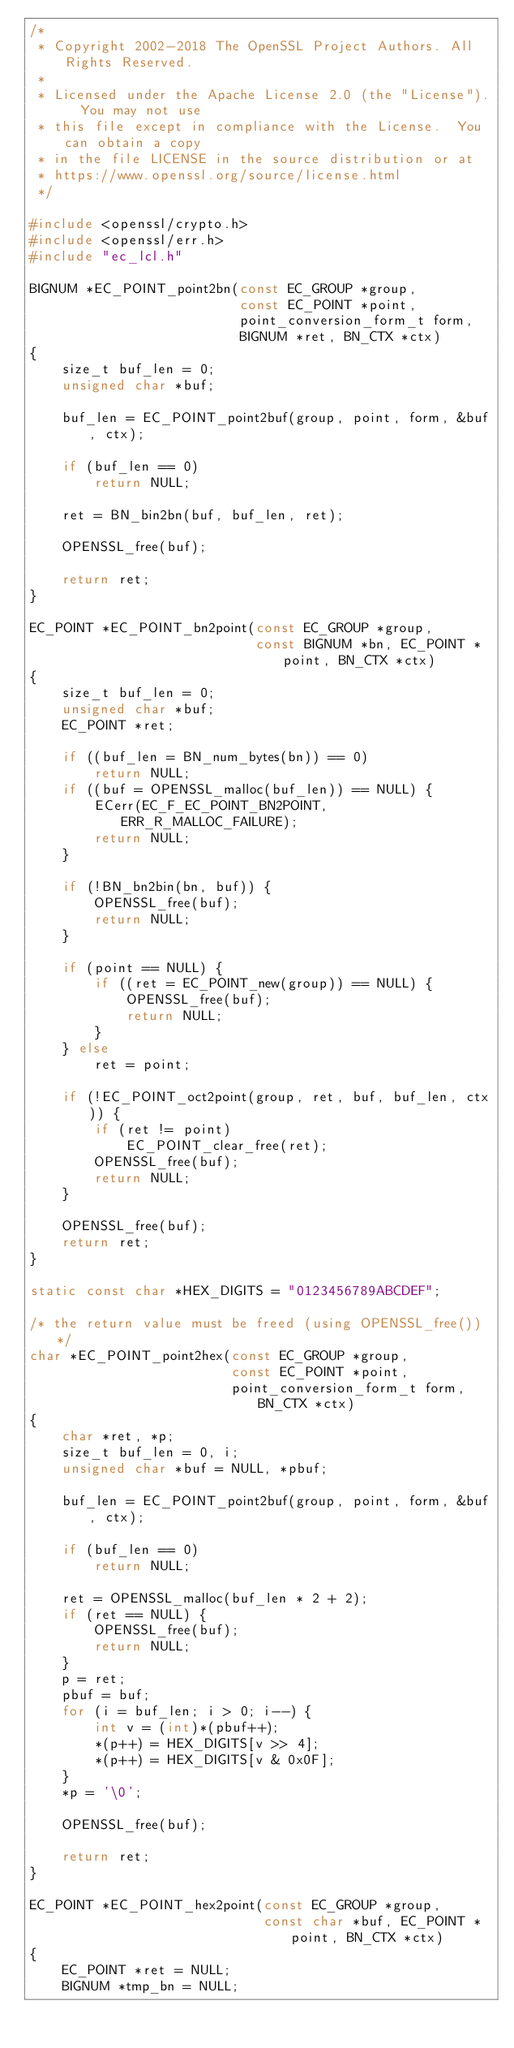<code> <loc_0><loc_0><loc_500><loc_500><_C_>/*
 * Copyright 2002-2018 The OpenSSL Project Authors. All Rights Reserved.
 *
 * Licensed under the Apache License 2.0 (the "License").  You may not use
 * this file except in compliance with the License.  You can obtain a copy
 * in the file LICENSE in the source distribution or at
 * https://www.openssl.org/source/license.html
 */

#include <openssl/crypto.h>
#include <openssl/err.h>
#include "ec_lcl.h"

BIGNUM *EC_POINT_point2bn(const EC_GROUP *group,
                          const EC_POINT *point,
                          point_conversion_form_t form,
                          BIGNUM *ret, BN_CTX *ctx)
{
    size_t buf_len = 0;
    unsigned char *buf;

    buf_len = EC_POINT_point2buf(group, point, form, &buf, ctx);

    if (buf_len == 0)
        return NULL;

    ret = BN_bin2bn(buf, buf_len, ret);

    OPENSSL_free(buf);

    return ret;
}

EC_POINT *EC_POINT_bn2point(const EC_GROUP *group,
                            const BIGNUM *bn, EC_POINT *point, BN_CTX *ctx)
{
    size_t buf_len = 0;
    unsigned char *buf;
    EC_POINT *ret;

    if ((buf_len = BN_num_bytes(bn)) == 0)
        return NULL;
    if ((buf = OPENSSL_malloc(buf_len)) == NULL) {
        ECerr(EC_F_EC_POINT_BN2POINT, ERR_R_MALLOC_FAILURE);
        return NULL;
    }

    if (!BN_bn2bin(bn, buf)) {
        OPENSSL_free(buf);
        return NULL;
    }

    if (point == NULL) {
        if ((ret = EC_POINT_new(group)) == NULL) {
            OPENSSL_free(buf);
            return NULL;
        }
    } else
        ret = point;

    if (!EC_POINT_oct2point(group, ret, buf, buf_len, ctx)) {
        if (ret != point)
            EC_POINT_clear_free(ret);
        OPENSSL_free(buf);
        return NULL;
    }

    OPENSSL_free(buf);
    return ret;
}

static const char *HEX_DIGITS = "0123456789ABCDEF";

/* the return value must be freed (using OPENSSL_free()) */
char *EC_POINT_point2hex(const EC_GROUP *group,
                         const EC_POINT *point,
                         point_conversion_form_t form, BN_CTX *ctx)
{
    char *ret, *p;
    size_t buf_len = 0, i;
    unsigned char *buf = NULL, *pbuf;

    buf_len = EC_POINT_point2buf(group, point, form, &buf, ctx);

    if (buf_len == 0)
        return NULL;

    ret = OPENSSL_malloc(buf_len * 2 + 2);
    if (ret == NULL) {
        OPENSSL_free(buf);
        return NULL;
    }
    p = ret;
    pbuf = buf;
    for (i = buf_len; i > 0; i--) {
        int v = (int)*(pbuf++);
        *(p++) = HEX_DIGITS[v >> 4];
        *(p++) = HEX_DIGITS[v & 0x0F];
    }
    *p = '\0';

    OPENSSL_free(buf);

    return ret;
}

EC_POINT *EC_POINT_hex2point(const EC_GROUP *group,
                             const char *buf, EC_POINT *point, BN_CTX *ctx)
{
    EC_POINT *ret = NULL;
    BIGNUM *tmp_bn = NULL;
</code> 